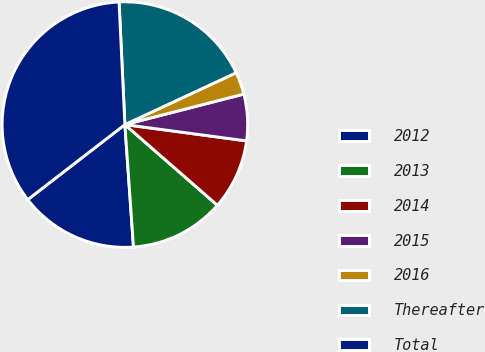Convert chart to OTSL. <chart><loc_0><loc_0><loc_500><loc_500><pie_chart><fcel>2012<fcel>2013<fcel>2014<fcel>2015<fcel>2016<fcel>Thereafter<fcel>Total<nl><fcel>15.65%<fcel>12.47%<fcel>9.29%<fcel>6.12%<fcel>2.94%<fcel>18.82%<fcel>34.71%<nl></chart> 